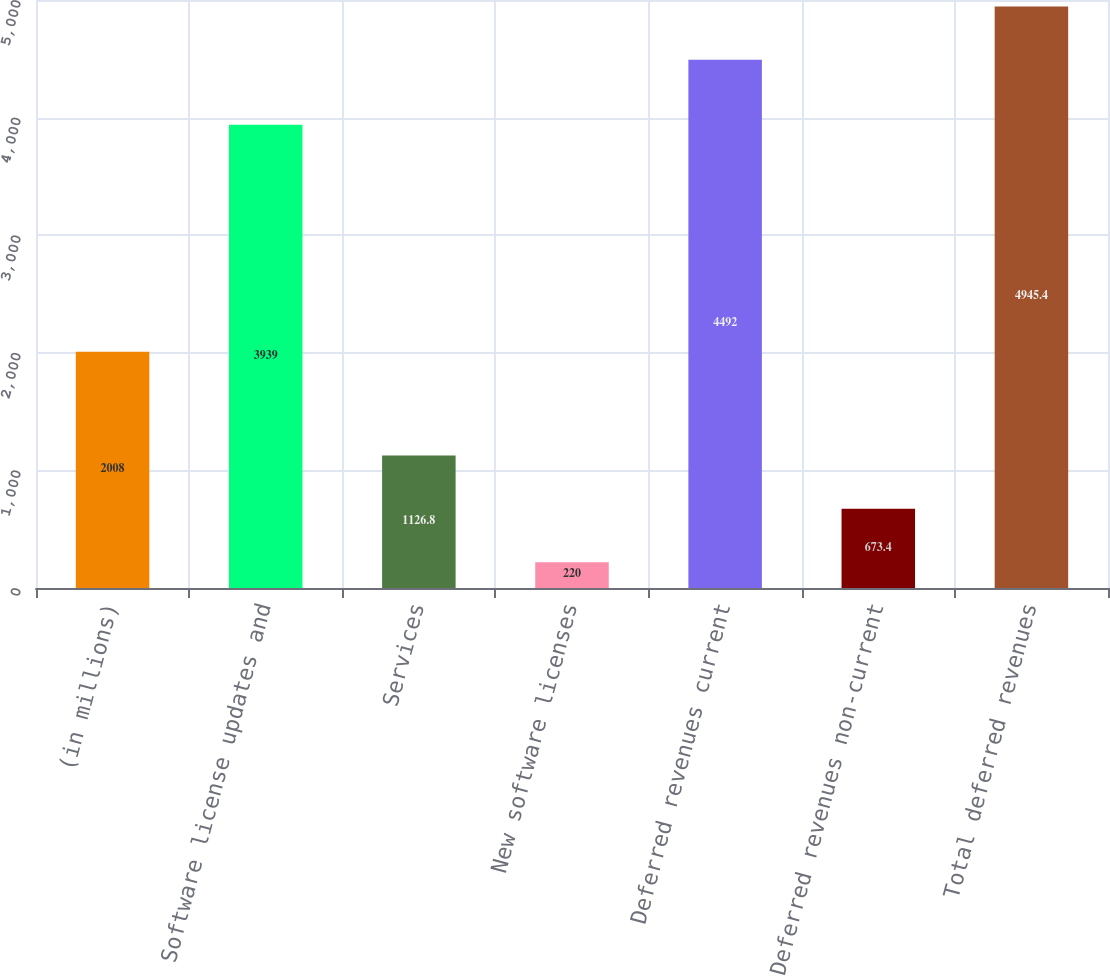Convert chart. <chart><loc_0><loc_0><loc_500><loc_500><bar_chart><fcel>(in millions)<fcel>Software license updates and<fcel>Services<fcel>New software licenses<fcel>Deferred revenues current<fcel>Deferred revenues non-current<fcel>Total deferred revenues<nl><fcel>2008<fcel>3939<fcel>1126.8<fcel>220<fcel>4492<fcel>673.4<fcel>4945.4<nl></chart> 